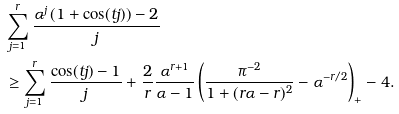Convert formula to latex. <formula><loc_0><loc_0><loc_500><loc_500>& \sum _ { j = 1 } ^ { r } \frac { \alpha ^ { j } \left ( 1 + \cos ( t j ) \right ) - 2 } { j } \\ & \geq \sum _ { j = 1 } ^ { r } \frac { \cos ( t j ) - 1 } { j } + \frac { 2 } { r } \frac { \alpha ^ { r + 1 } } { \alpha - 1 } \left ( \frac { \pi ^ { - 2 } } { 1 + ( r \alpha - r ) ^ { 2 } } - \alpha ^ { - r / 2 } \right ) _ { + } - 4 .</formula> 